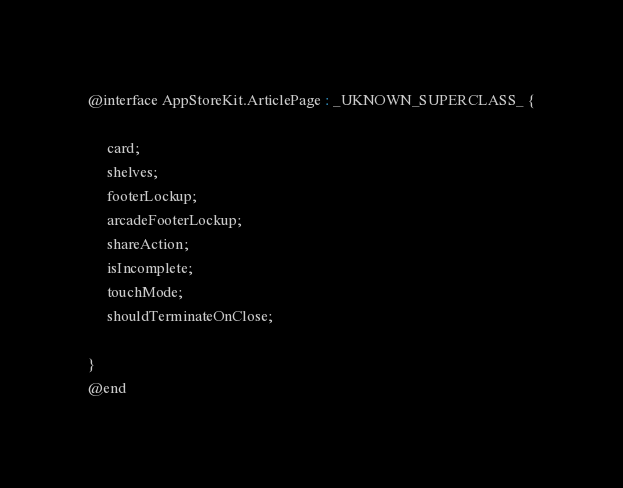Convert code to text. <code><loc_0><loc_0><loc_500><loc_500><_C_>

@interface AppStoreKit.ArticlePage : _UKNOWN_SUPERCLASS_ {

	 card;
	 shelves;
	 footerLockup;
	 arcadeFooterLockup;
	 shareAction;
	 isIncomplete;
	 touchMode;
	 shouldTerminateOnClose;

}
@end

</code> 